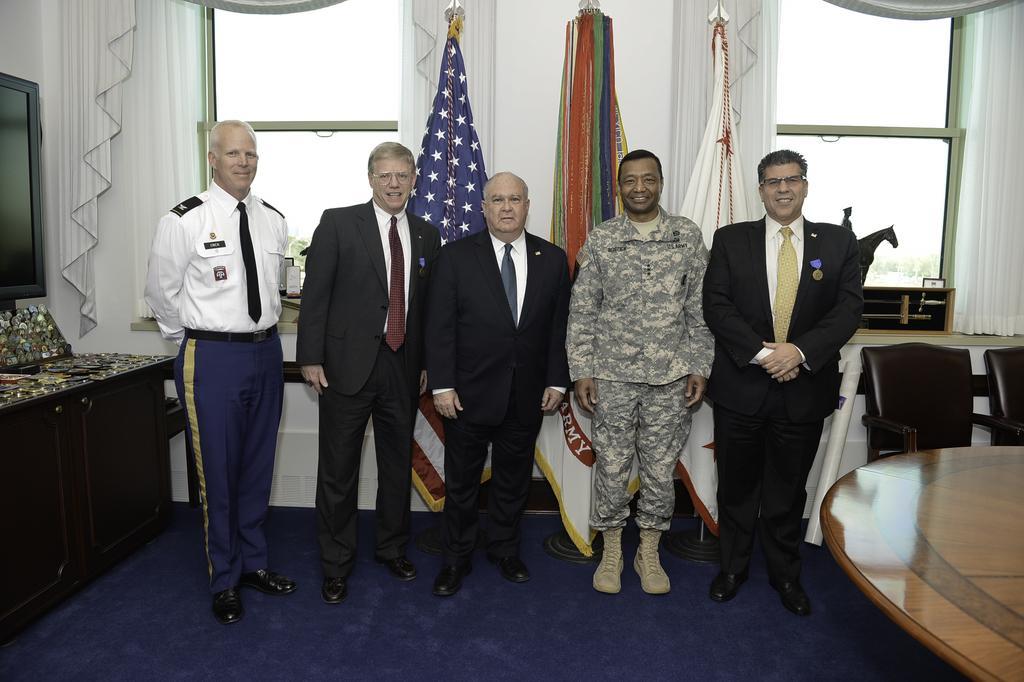Describe this image in one or two sentences. In this image I can see few persons are standing on the blue colored floor. I can see a brown colored table, few chairs which are black in color, a black colored screen, the white colored wall, few windows, few curtains and few flags. 